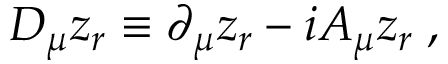<formula> <loc_0><loc_0><loc_500><loc_500>D _ { \mu } z _ { r } \equiv \partial _ { \mu } z _ { r } - i A _ { \mu } z _ { r } \, ,</formula> 